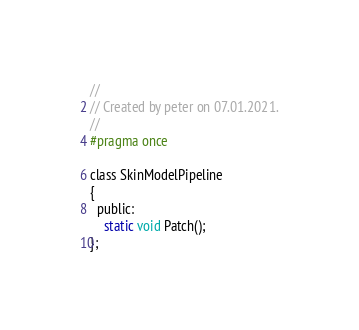Convert code to text. <code><loc_0><loc_0><loc_500><loc_500><_C_>//
// Created by peter on 07.01.2021.
//
#pragma once

class SkinModelPipeline
{
  public:
    static void Patch();
};</code> 